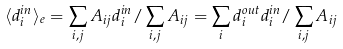<formula> <loc_0><loc_0><loc_500><loc_500>\langle d _ { i } ^ { i n } \rangle _ { e } = \sum _ { i , j } A _ { i j } d _ { i } ^ { i n } / \sum _ { i , j } A _ { i j } = \sum _ { i } d _ { i } ^ { o u t } d _ { i } ^ { i n } / \sum _ { i , j } A _ { i j }</formula> 